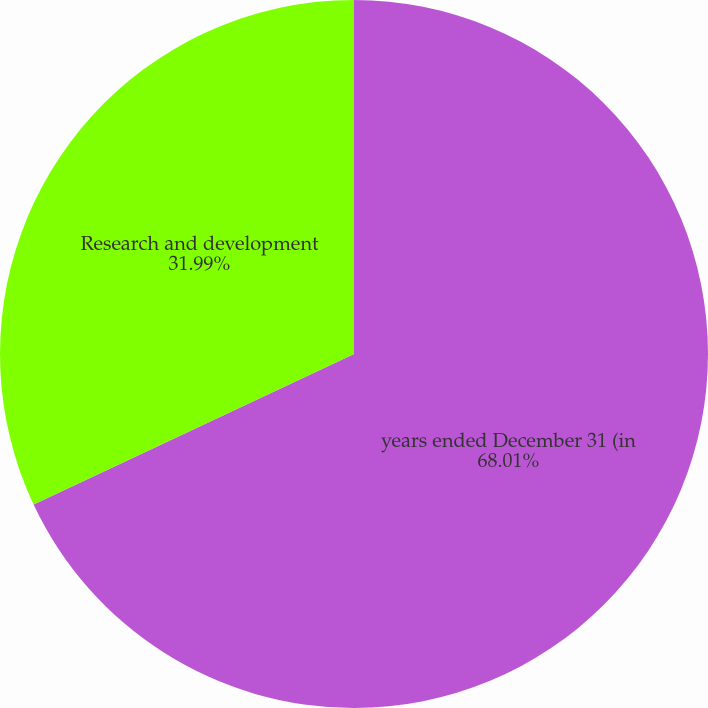Convert chart to OTSL. <chart><loc_0><loc_0><loc_500><loc_500><pie_chart><fcel>years ended December 31 (in<fcel>Research and development<nl><fcel>68.01%<fcel>31.99%<nl></chart> 